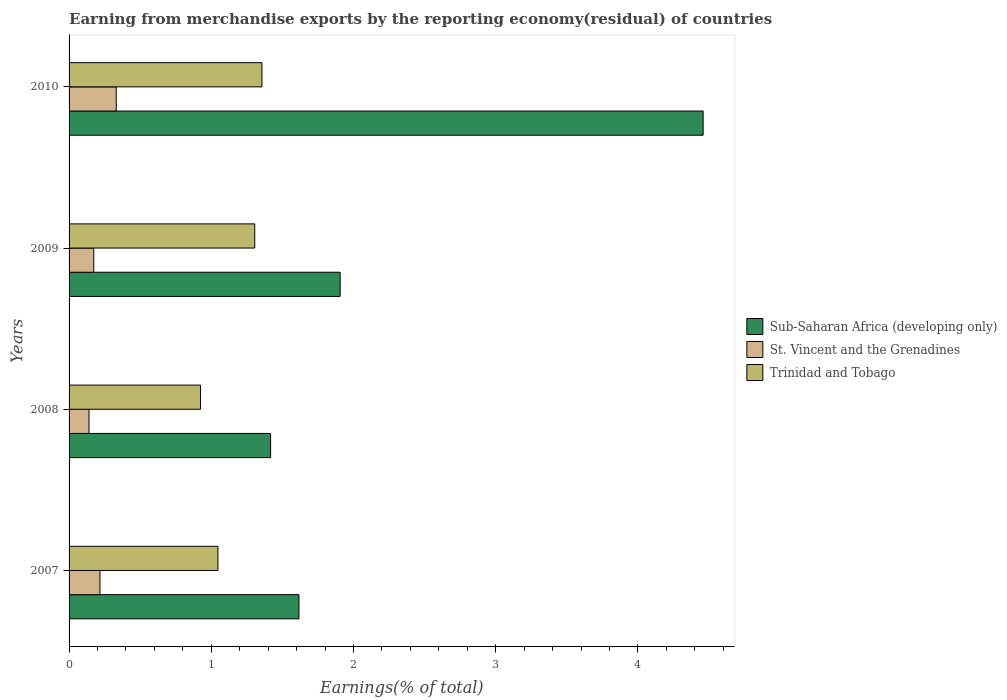How many bars are there on the 3rd tick from the bottom?
Ensure brevity in your answer.  3. In how many cases, is the number of bars for a given year not equal to the number of legend labels?
Your answer should be very brief. 0. What is the percentage of amount earned from merchandise exports in Trinidad and Tobago in 2009?
Make the answer very short. 1.31. Across all years, what is the maximum percentage of amount earned from merchandise exports in Trinidad and Tobago?
Offer a terse response. 1.36. Across all years, what is the minimum percentage of amount earned from merchandise exports in Trinidad and Tobago?
Offer a very short reply. 0.92. In which year was the percentage of amount earned from merchandise exports in Sub-Saharan Africa (developing only) minimum?
Make the answer very short. 2008. What is the total percentage of amount earned from merchandise exports in Sub-Saharan Africa (developing only) in the graph?
Provide a short and direct response. 9.4. What is the difference between the percentage of amount earned from merchandise exports in Trinidad and Tobago in 2007 and that in 2008?
Your response must be concise. 0.12. What is the difference between the percentage of amount earned from merchandise exports in St. Vincent and the Grenadines in 2008 and the percentage of amount earned from merchandise exports in Sub-Saharan Africa (developing only) in 2007?
Make the answer very short. -1.48. What is the average percentage of amount earned from merchandise exports in Trinidad and Tobago per year?
Provide a succinct answer. 1.16. In the year 2008, what is the difference between the percentage of amount earned from merchandise exports in Sub-Saharan Africa (developing only) and percentage of amount earned from merchandise exports in Trinidad and Tobago?
Your answer should be compact. 0.49. What is the ratio of the percentage of amount earned from merchandise exports in St. Vincent and the Grenadines in 2007 to that in 2009?
Give a very brief answer. 1.25. What is the difference between the highest and the second highest percentage of amount earned from merchandise exports in St. Vincent and the Grenadines?
Offer a terse response. 0.11. What is the difference between the highest and the lowest percentage of amount earned from merchandise exports in St. Vincent and the Grenadines?
Give a very brief answer. 0.19. In how many years, is the percentage of amount earned from merchandise exports in St. Vincent and the Grenadines greater than the average percentage of amount earned from merchandise exports in St. Vincent and the Grenadines taken over all years?
Keep it short and to the point. 2. Is the sum of the percentage of amount earned from merchandise exports in Trinidad and Tobago in 2007 and 2010 greater than the maximum percentage of amount earned from merchandise exports in Sub-Saharan Africa (developing only) across all years?
Make the answer very short. No. What does the 3rd bar from the top in 2007 represents?
Your answer should be very brief. Sub-Saharan Africa (developing only). What does the 1st bar from the bottom in 2009 represents?
Offer a terse response. Sub-Saharan Africa (developing only). Is it the case that in every year, the sum of the percentage of amount earned from merchandise exports in Trinidad and Tobago and percentage of amount earned from merchandise exports in St. Vincent and the Grenadines is greater than the percentage of amount earned from merchandise exports in Sub-Saharan Africa (developing only)?
Your response must be concise. No. Are the values on the major ticks of X-axis written in scientific E-notation?
Offer a very short reply. No. How many legend labels are there?
Ensure brevity in your answer.  3. How are the legend labels stacked?
Your answer should be compact. Vertical. What is the title of the graph?
Offer a very short reply. Earning from merchandise exports by the reporting economy(residual) of countries. Does "North America" appear as one of the legend labels in the graph?
Ensure brevity in your answer.  No. What is the label or title of the X-axis?
Give a very brief answer. Earnings(% of total). What is the label or title of the Y-axis?
Make the answer very short. Years. What is the Earnings(% of total) of Sub-Saharan Africa (developing only) in 2007?
Your answer should be very brief. 1.62. What is the Earnings(% of total) in St. Vincent and the Grenadines in 2007?
Give a very brief answer. 0.22. What is the Earnings(% of total) of Trinidad and Tobago in 2007?
Provide a succinct answer. 1.05. What is the Earnings(% of total) of Sub-Saharan Africa (developing only) in 2008?
Your answer should be very brief. 1.42. What is the Earnings(% of total) of St. Vincent and the Grenadines in 2008?
Offer a terse response. 0.14. What is the Earnings(% of total) of Trinidad and Tobago in 2008?
Offer a very short reply. 0.92. What is the Earnings(% of total) in Sub-Saharan Africa (developing only) in 2009?
Your answer should be compact. 1.91. What is the Earnings(% of total) in St. Vincent and the Grenadines in 2009?
Provide a short and direct response. 0.17. What is the Earnings(% of total) of Trinidad and Tobago in 2009?
Give a very brief answer. 1.31. What is the Earnings(% of total) in Sub-Saharan Africa (developing only) in 2010?
Provide a succinct answer. 4.46. What is the Earnings(% of total) of St. Vincent and the Grenadines in 2010?
Your answer should be compact. 0.33. What is the Earnings(% of total) in Trinidad and Tobago in 2010?
Your answer should be very brief. 1.36. Across all years, what is the maximum Earnings(% of total) in Sub-Saharan Africa (developing only)?
Your response must be concise. 4.46. Across all years, what is the maximum Earnings(% of total) in St. Vincent and the Grenadines?
Provide a short and direct response. 0.33. Across all years, what is the maximum Earnings(% of total) of Trinidad and Tobago?
Offer a very short reply. 1.36. Across all years, what is the minimum Earnings(% of total) of Sub-Saharan Africa (developing only)?
Provide a short and direct response. 1.42. Across all years, what is the minimum Earnings(% of total) of St. Vincent and the Grenadines?
Your response must be concise. 0.14. Across all years, what is the minimum Earnings(% of total) in Trinidad and Tobago?
Ensure brevity in your answer.  0.92. What is the total Earnings(% of total) of Sub-Saharan Africa (developing only) in the graph?
Give a very brief answer. 9.4. What is the total Earnings(% of total) of St. Vincent and the Grenadines in the graph?
Provide a short and direct response. 0.86. What is the total Earnings(% of total) of Trinidad and Tobago in the graph?
Make the answer very short. 4.63. What is the difference between the Earnings(% of total) of Sub-Saharan Africa (developing only) in 2007 and that in 2008?
Your answer should be very brief. 0.2. What is the difference between the Earnings(% of total) of St. Vincent and the Grenadines in 2007 and that in 2008?
Make the answer very short. 0.08. What is the difference between the Earnings(% of total) in Trinidad and Tobago in 2007 and that in 2008?
Provide a short and direct response. 0.12. What is the difference between the Earnings(% of total) of Sub-Saharan Africa (developing only) in 2007 and that in 2009?
Offer a very short reply. -0.29. What is the difference between the Earnings(% of total) in St. Vincent and the Grenadines in 2007 and that in 2009?
Ensure brevity in your answer.  0.04. What is the difference between the Earnings(% of total) in Trinidad and Tobago in 2007 and that in 2009?
Offer a terse response. -0.26. What is the difference between the Earnings(% of total) in Sub-Saharan Africa (developing only) in 2007 and that in 2010?
Ensure brevity in your answer.  -2.84. What is the difference between the Earnings(% of total) in St. Vincent and the Grenadines in 2007 and that in 2010?
Offer a terse response. -0.11. What is the difference between the Earnings(% of total) in Trinidad and Tobago in 2007 and that in 2010?
Provide a succinct answer. -0.31. What is the difference between the Earnings(% of total) in Sub-Saharan Africa (developing only) in 2008 and that in 2009?
Offer a terse response. -0.49. What is the difference between the Earnings(% of total) of St. Vincent and the Grenadines in 2008 and that in 2009?
Offer a very short reply. -0.03. What is the difference between the Earnings(% of total) of Trinidad and Tobago in 2008 and that in 2009?
Ensure brevity in your answer.  -0.38. What is the difference between the Earnings(% of total) of Sub-Saharan Africa (developing only) in 2008 and that in 2010?
Your answer should be compact. -3.04. What is the difference between the Earnings(% of total) of St. Vincent and the Grenadines in 2008 and that in 2010?
Your answer should be compact. -0.19. What is the difference between the Earnings(% of total) of Trinidad and Tobago in 2008 and that in 2010?
Your response must be concise. -0.43. What is the difference between the Earnings(% of total) of Sub-Saharan Africa (developing only) in 2009 and that in 2010?
Make the answer very short. -2.55. What is the difference between the Earnings(% of total) in St. Vincent and the Grenadines in 2009 and that in 2010?
Your answer should be very brief. -0.16. What is the difference between the Earnings(% of total) of Trinidad and Tobago in 2009 and that in 2010?
Ensure brevity in your answer.  -0.05. What is the difference between the Earnings(% of total) of Sub-Saharan Africa (developing only) in 2007 and the Earnings(% of total) of St. Vincent and the Grenadines in 2008?
Your response must be concise. 1.48. What is the difference between the Earnings(% of total) of Sub-Saharan Africa (developing only) in 2007 and the Earnings(% of total) of Trinidad and Tobago in 2008?
Offer a terse response. 0.69. What is the difference between the Earnings(% of total) in St. Vincent and the Grenadines in 2007 and the Earnings(% of total) in Trinidad and Tobago in 2008?
Provide a short and direct response. -0.71. What is the difference between the Earnings(% of total) in Sub-Saharan Africa (developing only) in 2007 and the Earnings(% of total) in St. Vincent and the Grenadines in 2009?
Provide a succinct answer. 1.44. What is the difference between the Earnings(% of total) in Sub-Saharan Africa (developing only) in 2007 and the Earnings(% of total) in Trinidad and Tobago in 2009?
Your answer should be very brief. 0.31. What is the difference between the Earnings(% of total) of St. Vincent and the Grenadines in 2007 and the Earnings(% of total) of Trinidad and Tobago in 2009?
Make the answer very short. -1.09. What is the difference between the Earnings(% of total) of Sub-Saharan Africa (developing only) in 2007 and the Earnings(% of total) of St. Vincent and the Grenadines in 2010?
Offer a terse response. 1.28. What is the difference between the Earnings(% of total) in Sub-Saharan Africa (developing only) in 2007 and the Earnings(% of total) in Trinidad and Tobago in 2010?
Your answer should be compact. 0.26. What is the difference between the Earnings(% of total) of St. Vincent and the Grenadines in 2007 and the Earnings(% of total) of Trinidad and Tobago in 2010?
Ensure brevity in your answer.  -1.14. What is the difference between the Earnings(% of total) of Sub-Saharan Africa (developing only) in 2008 and the Earnings(% of total) of St. Vincent and the Grenadines in 2009?
Offer a terse response. 1.24. What is the difference between the Earnings(% of total) in Sub-Saharan Africa (developing only) in 2008 and the Earnings(% of total) in Trinidad and Tobago in 2009?
Your answer should be compact. 0.11. What is the difference between the Earnings(% of total) in St. Vincent and the Grenadines in 2008 and the Earnings(% of total) in Trinidad and Tobago in 2009?
Your answer should be compact. -1.17. What is the difference between the Earnings(% of total) in Sub-Saharan Africa (developing only) in 2008 and the Earnings(% of total) in St. Vincent and the Grenadines in 2010?
Ensure brevity in your answer.  1.09. What is the difference between the Earnings(% of total) in Sub-Saharan Africa (developing only) in 2008 and the Earnings(% of total) in Trinidad and Tobago in 2010?
Give a very brief answer. 0.06. What is the difference between the Earnings(% of total) of St. Vincent and the Grenadines in 2008 and the Earnings(% of total) of Trinidad and Tobago in 2010?
Your response must be concise. -1.22. What is the difference between the Earnings(% of total) of Sub-Saharan Africa (developing only) in 2009 and the Earnings(% of total) of St. Vincent and the Grenadines in 2010?
Your response must be concise. 1.57. What is the difference between the Earnings(% of total) of Sub-Saharan Africa (developing only) in 2009 and the Earnings(% of total) of Trinidad and Tobago in 2010?
Offer a terse response. 0.55. What is the difference between the Earnings(% of total) of St. Vincent and the Grenadines in 2009 and the Earnings(% of total) of Trinidad and Tobago in 2010?
Provide a short and direct response. -1.18. What is the average Earnings(% of total) in Sub-Saharan Africa (developing only) per year?
Your answer should be very brief. 2.35. What is the average Earnings(% of total) in St. Vincent and the Grenadines per year?
Your response must be concise. 0.22. What is the average Earnings(% of total) in Trinidad and Tobago per year?
Keep it short and to the point. 1.16. In the year 2007, what is the difference between the Earnings(% of total) of Sub-Saharan Africa (developing only) and Earnings(% of total) of St. Vincent and the Grenadines?
Give a very brief answer. 1.4. In the year 2007, what is the difference between the Earnings(% of total) in Sub-Saharan Africa (developing only) and Earnings(% of total) in Trinidad and Tobago?
Provide a short and direct response. 0.57. In the year 2007, what is the difference between the Earnings(% of total) in St. Vincent and the Grenadines and Earnings(% of total) in Trinidad and Tobago?
Ensure brevity in your answer.  -0.83. In the year 2008, what is the difference between the Earnings(% of total) in Sub-Saharan Africa (developing only) and Earnings(% of total) in St. Vincent and the Grenadines?
Give a very brief answer. 1.28. In the year 2008, what is the difference between the Earnings(% of total) in Sub-Saharan Africa (developing only) and Earnings(% of total) in Trinidad and Tobago?
Make the answer very short. 0.49. In the year 2008, what is the difference between the Earnings(% of total) in St. Vincent and the Grenadines and Earnings(% of total) in Trinidad and Tobago?
Offer a very short reply. -0.78. In the year 2009, what is the difference between the Earnings(% of total) in Sub-Saharan Africa (developing only) and Earnings(% of total) in St. Vincent and the Grenadines?
Give a very brief answer. 1.73. In the year 2009, what is the difference between the Earnings(% of total) of Sub-Saharan Africa (developing only) and Earnings(% of total) of Trinidad and Tobago?
Offer a terse response. 0.6. In the year 2009, what is the difference between the Earnings(% of total) in St. Vincent and the Grenadines and Earnings(% of total) in Trinidad and Tobago?
Offer a terse response. -1.13. In the year 2010, what is the difference between the Earnings(% of total) in Sub-Saharan Africa (developing only) and Earnings(% of total) in St. Vincent and the Grenadines?
Your response must be concise. 4.13. In the year 2010, what is the difference between the Earnings(% of total) in Sub-Saharan Africa (developing only) and Earnings(% of total) in Trinidad and Tobago?
Offer a very short reply. 3.1. In the year 2010, what is the difference between the Earnings(% of total) in St. Vincent and the Grenadines and Earnings(% of total) in Trinidad and Tobago?
Keep it short and to the point. -1.02. What is the ratio of the Earnings(% of total) in Sub-Saharan Africa (developing only) in 2007 to that in 2008?
Your response must be concise. 1.14. What is the ratio of the Earnings(% of total) in St. Vincent and the Grenadines in 2007 to that in 2008?
Provide a short and direct response. 1.55. What is the ratio of the Earnings(% of total) of Trinidad and Tobago in 2007 to that in 2008?
Your answer should be compact. 1.13. What is the ratio of the Earnings(% of total) in Sub-Saharan Africa (developing only) in 2007 to that in 2009?
Keep it short and to the point. 0.85. What is the ratio of the Earnings(% of total) of St. Vincent and the Grenadines in 2007 to that in 2009?
Give a very brief answer. 1.25. What is the ratio of the Earnings(% of total) in Trinidad and Tobago in 2007 to that in 2009?
Offer a very short reply. 0.8. What is the ratio of the Earnings(% of total) in Sub-Saharan Africa (developing only) in 2007 to that in 2010?
Your response must be concise. 0.36. What is the ratio of the Earnings(% of total) in St. Vincent and the Grenadines in 2007 to that in 2010?
Your answer should be compact. 0.66. What is the ratio of the Earnings(% of total) of Trinidad and Tobago in 2007 to that in 2010?
Your response must be concise. 0.77. What is the ratio of the Earnings(% of total) of Sub-Saharan Africa (developing only) in 2008 to that in 2009?
Offer a very short reply. 0.74. What is the ratio of the Earnings(% of total) of St. Vincent and the Grenadines in 2008 to that in 2009?
Make the answer very short. 0.81. What is the ratio of the Earnings(% of total) of Trinidad and Tobago in 2008 to that in 2009?
Offer a very short reply. 0.71. What is the ratio of the Earnings(% of total) of Sub-Saharan Africa (developing only) in 2008 to that in 2010?
Offer a terse response. 0.32. What is the ratio of the Earnings(% of total) of St. Vincent and the Grenadines in 2008 to that in 2010?
Give a very brief answer. 0.42. What is the ratio of the Earnings(% of total) in Trinidad and Tobago in 2008 to that in 2010?
Offer a terse response. 0.68. What is the ratio of the Earnings(% of total) of Sub-Saharan Africa (developing only) in 2009 to that in 2010?
Give a very brief answer. 0.43. What is the ratio of the Earnings(% of total) of St. Vincent and the Grenadines in 2009 to that in 2010?
Offer a terse response. 0.52. What is the ratio of the Earnings(% of total) in Trinidad and Tobago in 2009 to that in 2010?
Provide a short and direct response. 0.96. What is the difference between the highest and the second highest Earnings(% of total) of Sub-Saharan Africa (developing only)?
Your response must be concise. 2.55. What is the difference between the highest and the second highest Earnings(% of total) of St. Vincent and the Grenadines?
Offer a terse response. 0.11. What is the difference between the highest and the second highest Earnings(% of total) of Trinidad and Tobago?
Give a very brief answer. 0.05. What is the difference between the highest and the lowest Earnings(% of total) in Sub-Saharan Africa (developing only)?
Your answer should be compact. 3.04. What is the difference between the highest and the lowest Earnings(% of total) in St. Vincent and the Grenadines?
Offer a terse response. 0.19. What is the difference between the highest and the lowest Earnings(% of total) of Trinidad and Tobago?
Keep it short and to the point. 0.43. 